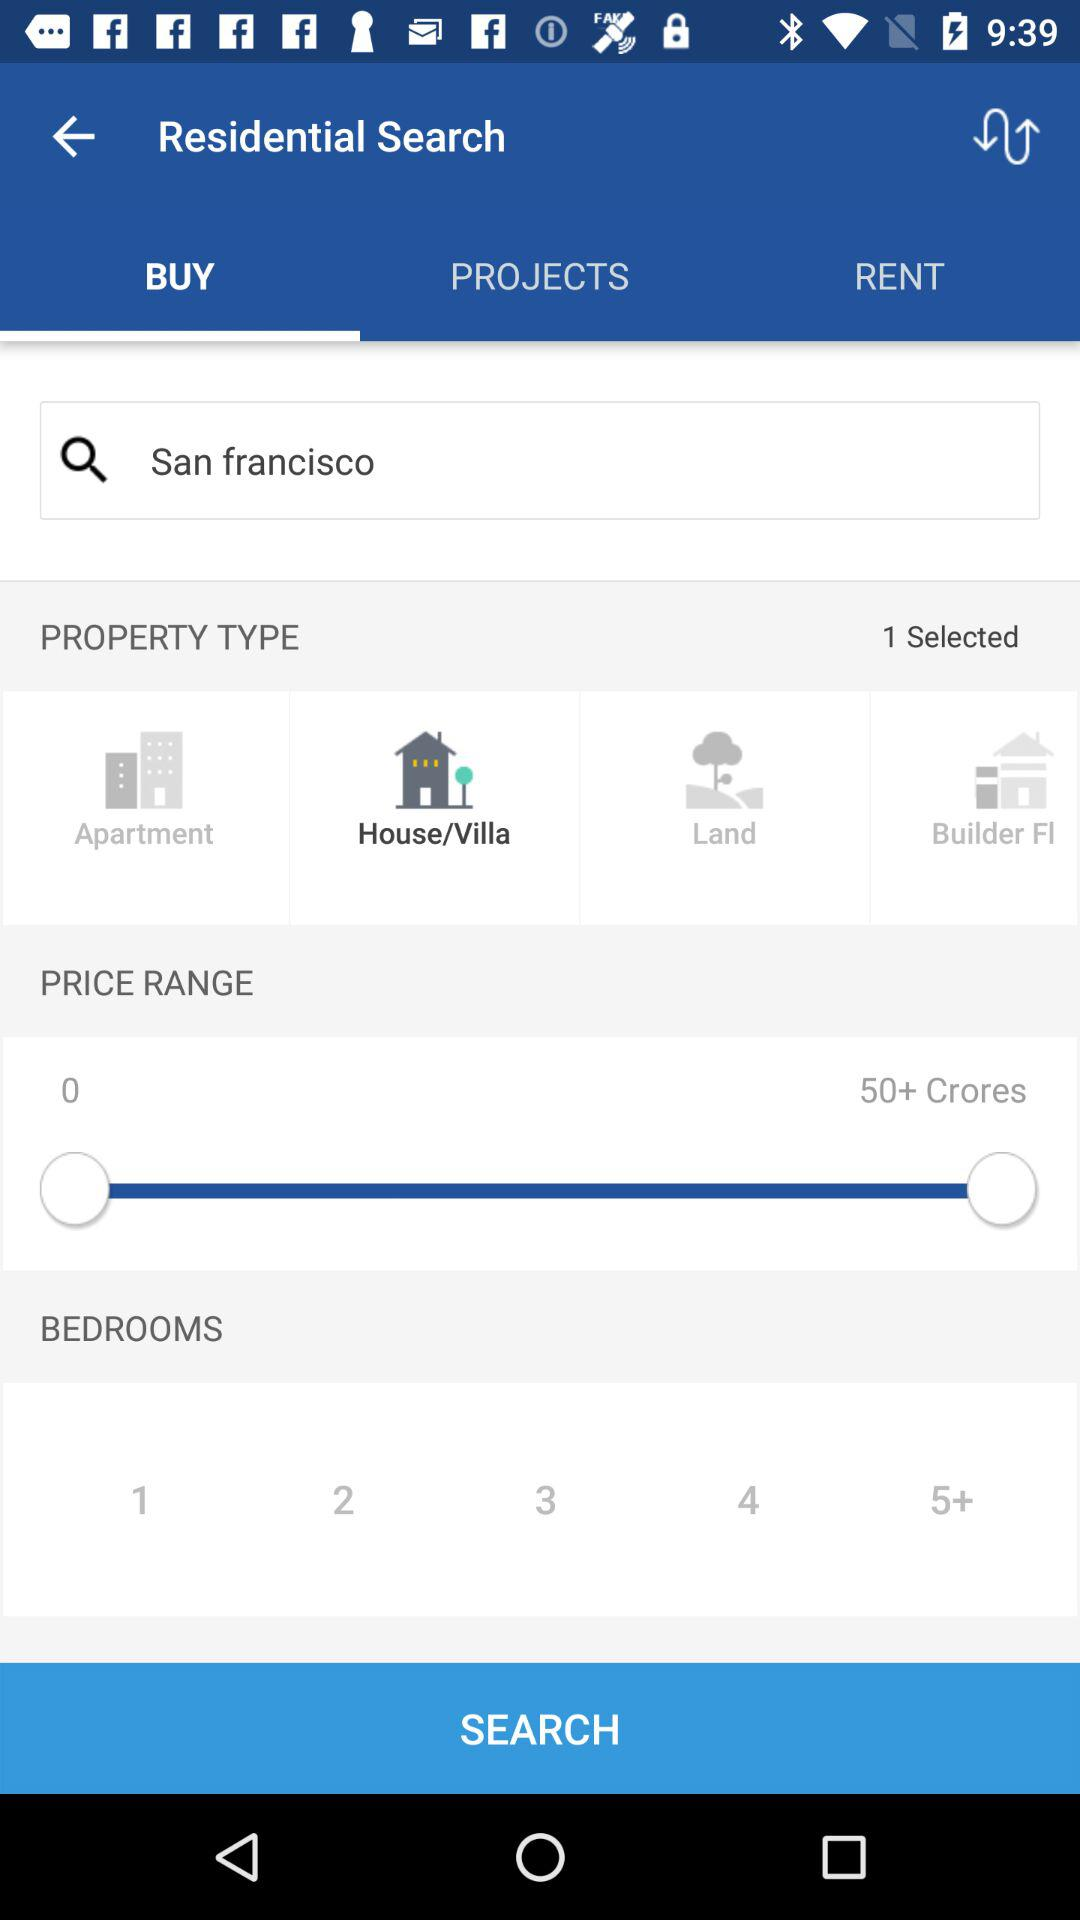How many bedrooms are available?
Answer the question using a single word or phrase. 1, 2, 3, 4, 5+ 